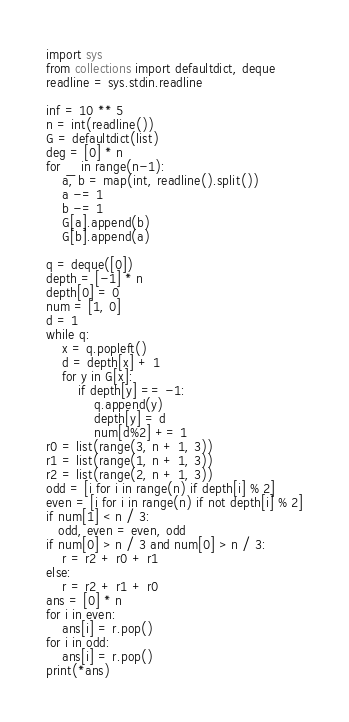Convert code to text. <code><loc_0><loc_0><loc_500><loc_500><_Python_>import sys
from collections import defaultdict, deque
readline = sys.stdin.readline

inf = 10 ** 5
n = int(readline())
G = defaultdict(list)
deg = [0] * n
for _ in range(n-1):
    a, b = map(int, readline().split())
    a -= 1
    b -= 1
    G[a].append(b)
    G[b].append(a)

q = deque([0])
depth = [-1] * n
depth[0] = 0
num = [1, 0]
d = 1
while q:
    x = q.popleft()
    d = depth[x] + 1
    for y in G[x]:
        if depth[y] == -1:
            q.append(y)
            depth[y] = d
            num[d%2] += 1
r0 = list(range(3, n + 1, 3))
r1 = list(range(1, n + 1, 3))
r2 = list(range(2, n + 1, 3))
odd = [i for i in range(n) if depth[i] % 2]
even = [i for i in range(n) if not depth[i] % 2]
if num[1] < n / 3:
   odd, even = even, odd
if num[0] > n / 3 and num[0] > n / 3:
    r = r2 + r0 + r1
else:
    r = r2 + r1 + r0
ans = [0] * n
for i in even:
    ans[i] = r.pop()
for i in odd:
    ans[i] = r.pop()
print(*ans)
</code> 